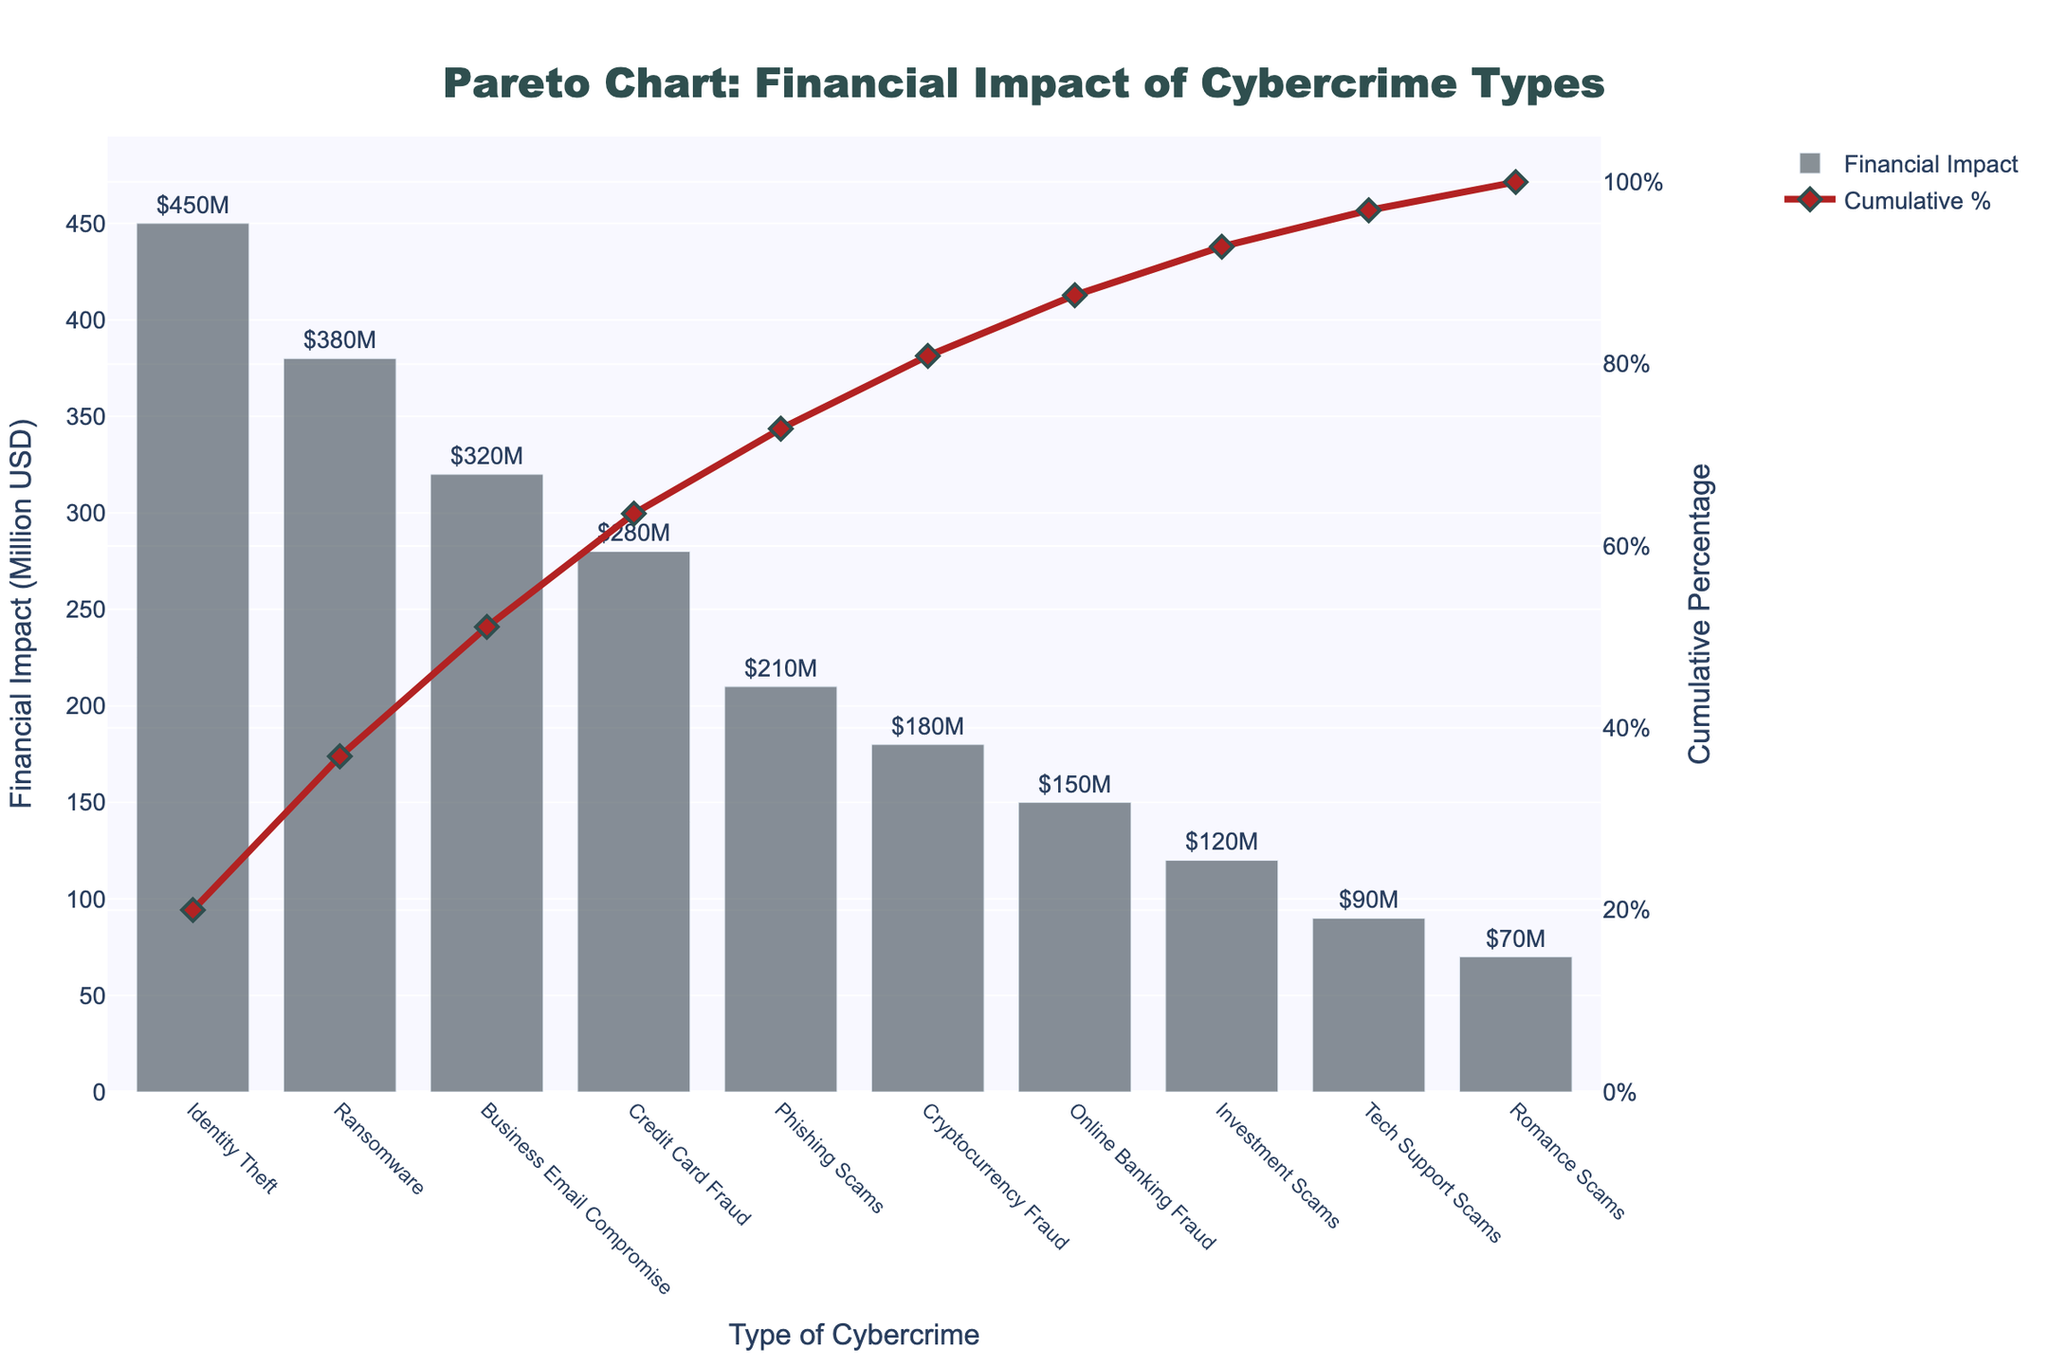How many types of cybercrime are shown in the figure? Count the number of bars in the bar chart representing different types of cybercrime.
Answer: 10 What is the title of the chart? Refer to the text at the top of the figure.
Answer: Pareto Chart: Financial Impact of Cybercrime Types Which type of cybercrime has the highest financial impact? Look at the tallest bar in the bar chart.
Answer: Identity Theft What is the cumulative percentage for the top 3 types of cybercrime? Sum the cumulative percentages for Identity Theft, Ransomware, and Business Email Compromise.
Answer: 63.24% Which type of cybercrime contributes to the cumulative percentage reaching over 80%? Identify the point where the cumulative percentage line crosses 80% and check the corresponding type of cybercrime.
Answer: Phishing Scams What are these 4 types of cybercrime with the highest financial impact? List them in order. List the top 4 tallest bars: Identity Theft, Ransomware, Business Email Compromise, and Credit Card Fraud.
Answer: Identity Theft, Ransomware, Business Email Compromise, Credit Card Fraud How much higher is the financial impact of Identity Theft compared to Tech Support Scams? Subtract the financial impact of Tech Support Scams from Identity Theft.
Answer: 360 million USD If the financial impact of Online Banking Fraud increased by 50 million USD, what would the new cumulative percentage be for the top 7 crimes? Increase Online Banking Fraud's impact by 50 million USD, recalculate its cumulative percentage, and then sum the top 7 cumulative percentages.
Answer: 86.7% Which type of cybercrime is just below the point when the cumulative percentage line reaches 50%? Look at the type of cybercrime where the cumulative percentage is just under 50%.
Answer: Business Email Compromise Between Credit Card Fraud and Tech Support Scams, which cybercrime has a lower financial impact? Compare the heights of the bars representing Credit Card Fraud and Tech Support Scams.
Answer: Tech Support Scams 